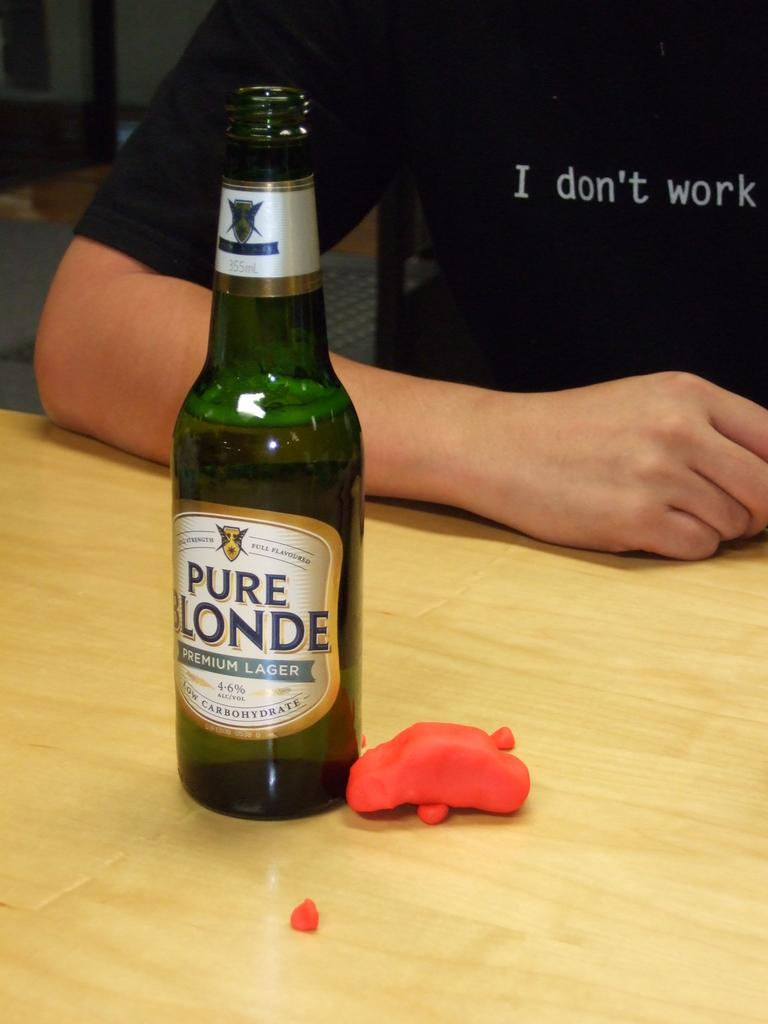Provide a one-sentence caption for the provided image. a Pure Londe drink bottle with someone who doesn't work next to it. 